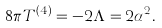<formula> <loc_0><loc_0><loc_500><loc_500>8 \pi T ^ { ( 4 ) } = - 2 \Lambda = 2 \alpha ^ { 2 } .</formula> 